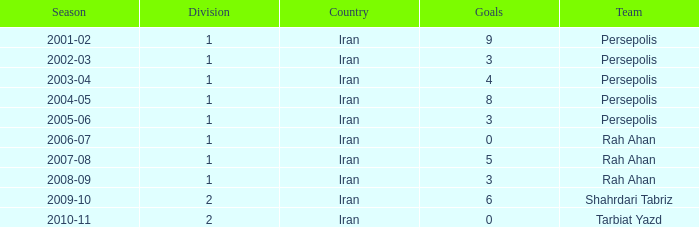What is the lowest Division, when Goals is less than 5, and when Season is "2002-03"? 1.0. 